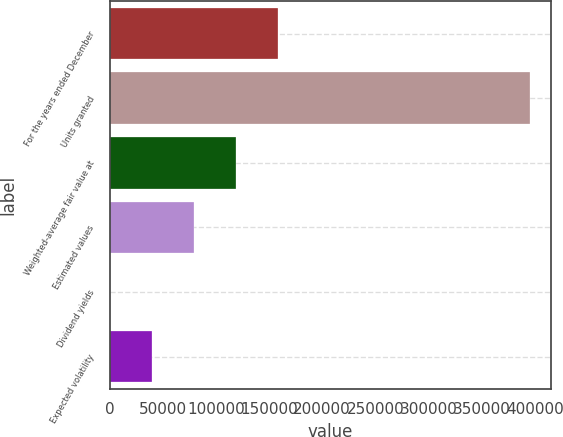Convert chart to OTSL. <chart><loc_0><loc_0><loc_500><loc_500><bar_chart><fcel>For the years ended December<fcel>Units granted<fcel>Weighted-average fair value at<fcel>Estimated values<fcel>Dividend yields<fcel>Expected volatility<nl><fcel>158346<fcel>395862<fcel>118760<fcel>79174<fcel>2<fcel>39588<nl></chart> 